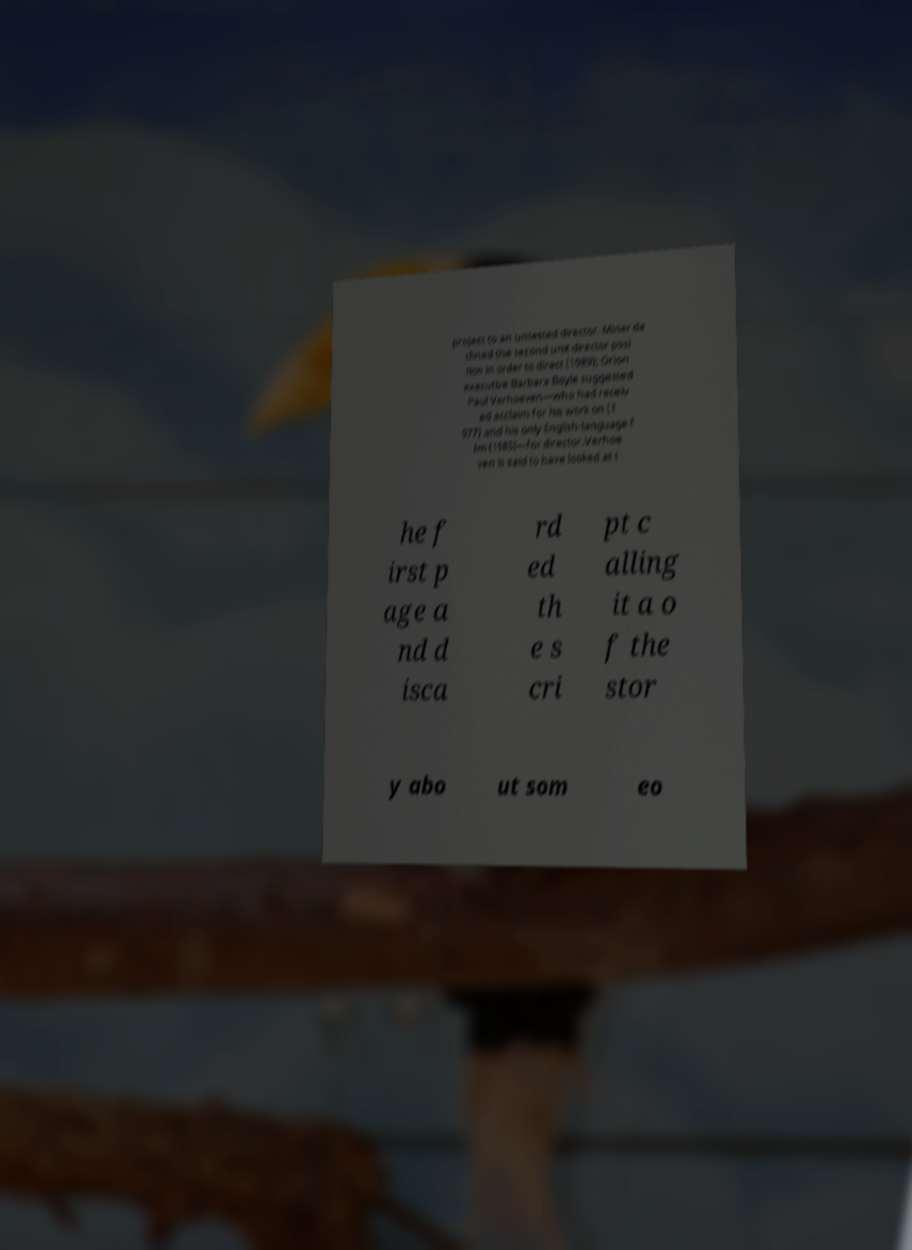For documentation purposes, I need the text within this image transcribed. Could you provide that? project to an untested director. Miner de clined the second unit director posi tion in order to direct (1989); Orion executive Barbara Boyle suggested Paul Verhoeven—who had receiv ed acclaim for his work on (1 977) and his only English-language f ilm (1985)—for director.Verhoe ven is said to have looked at t he f irst p age a nd d isca rd ed th e s cri pt c alling it a o f the stor y abo ut som eo 